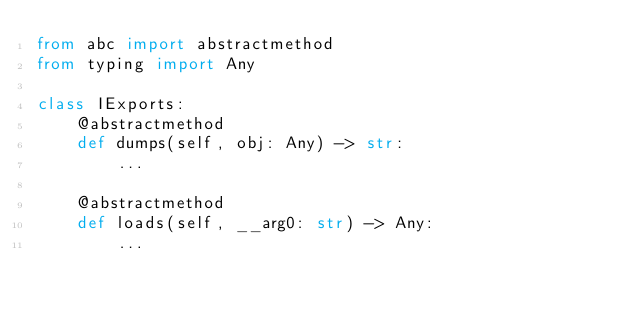<code> <loc_0><loc_0><loc_500><loc_500><_Python_>from abc import abstractmethod
from typing import Any

class IExports:
    @abstractmethod
    def dumps(self, obj: Any) -> str:
        ...
    
    @abstractmethod
    def loads(self, __arg0: str) -> Any:
        ...
    

</code> 